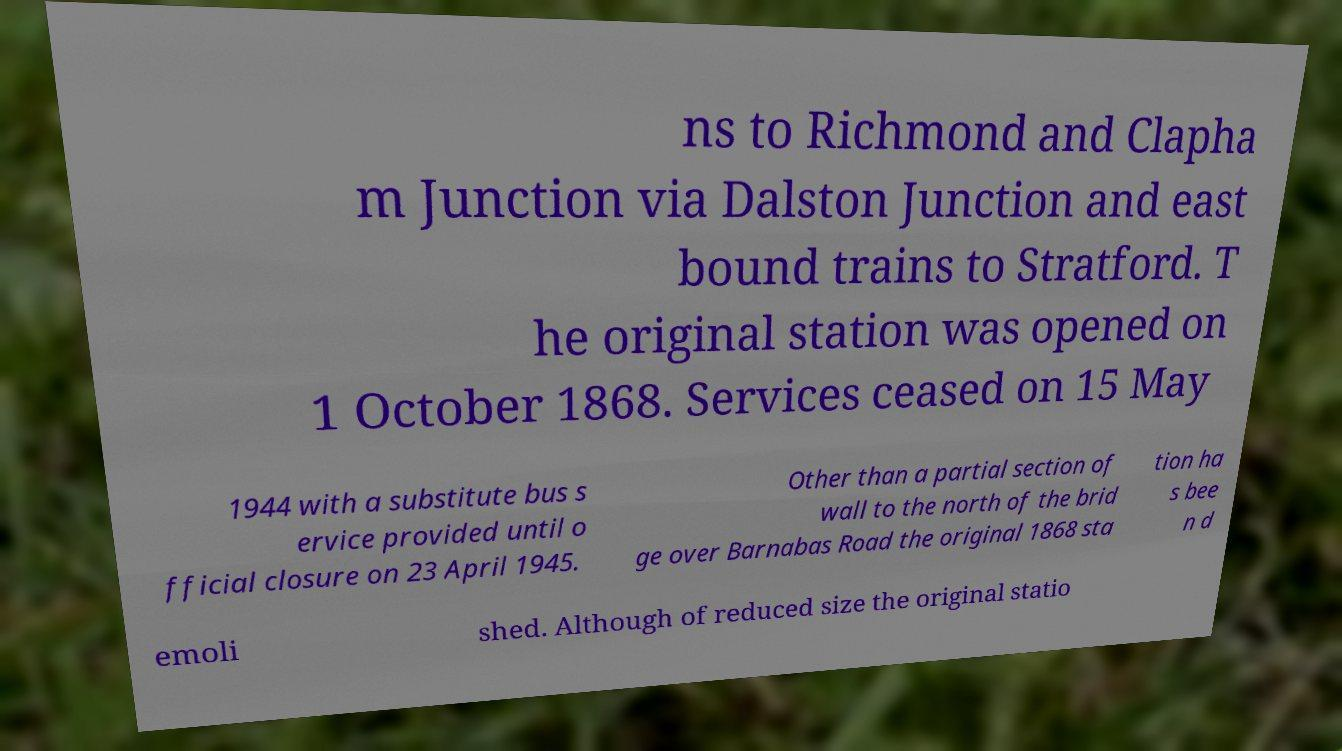Could you assist in decoding the text presented in this image and type it out clearly? ns to Richmond and Clapha m Junction via Dalston Junction and east bound trains to Stratford. T he original station was opened on 1 October 1868. Services ceased on 15 May 1944 with a substitute bus s ervice provided until o fficial closure on 23 April 1945. Other than a partial section of wall to the north of the brid ge over Barnabas Road the original 1868 sta tion ha s bee n d emoli shed. Although of reduced size the original statio 